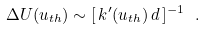Convert formula to latex. <formula><loc_0><loc_0><loc_500><loc_500>\Delta U ( u _ { t h } ) \sim [ \, k ^ { \prime } ( u _ { t h } ) \, d \, ] ^ { - 1 } \ .</formula> 